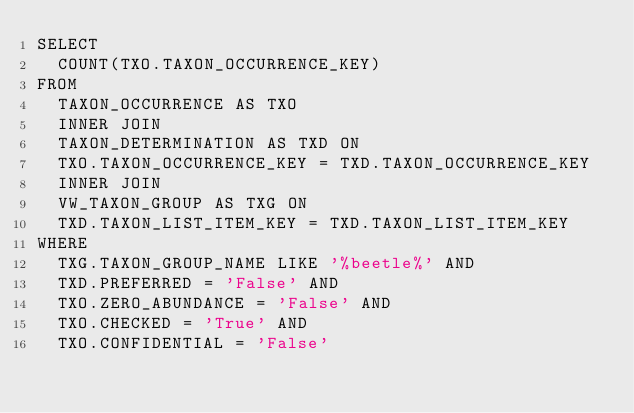Convert code to text. <code><loc_0><loc_0><loc_500><loc_500><_SQL_>SELECT
  COUNT(TXO.TAXON_OCCURRENCE_KEY)
FROM
  TAXON_OCCURRENCE AS TXO
  INNER JOIN
  TAXON_DETERMINATION AS TXD ON
  TXO.TAXON_OCCURRENCE_KEY = TXD.TAXON_OCCURRENCE_KEY
  INNER JOIN
  VW_TAXON_GROUP AS TXG ON
  TXD.TAXON_LIST_ITEM_KEY = TXD.TAXON_LIST_ITEM_KEY
WHERE
  TXG.TAXON_GROUP_NAME LIKE '%beetle%' AND
  TXD.PREFERRED = 'False' AND
  TXO.ZERO_ABUNDANCE = 'False' AND
  TXO.CHECKED = 'True' AND
  TXO.CONFIDENTIAL = 'False'</code> 